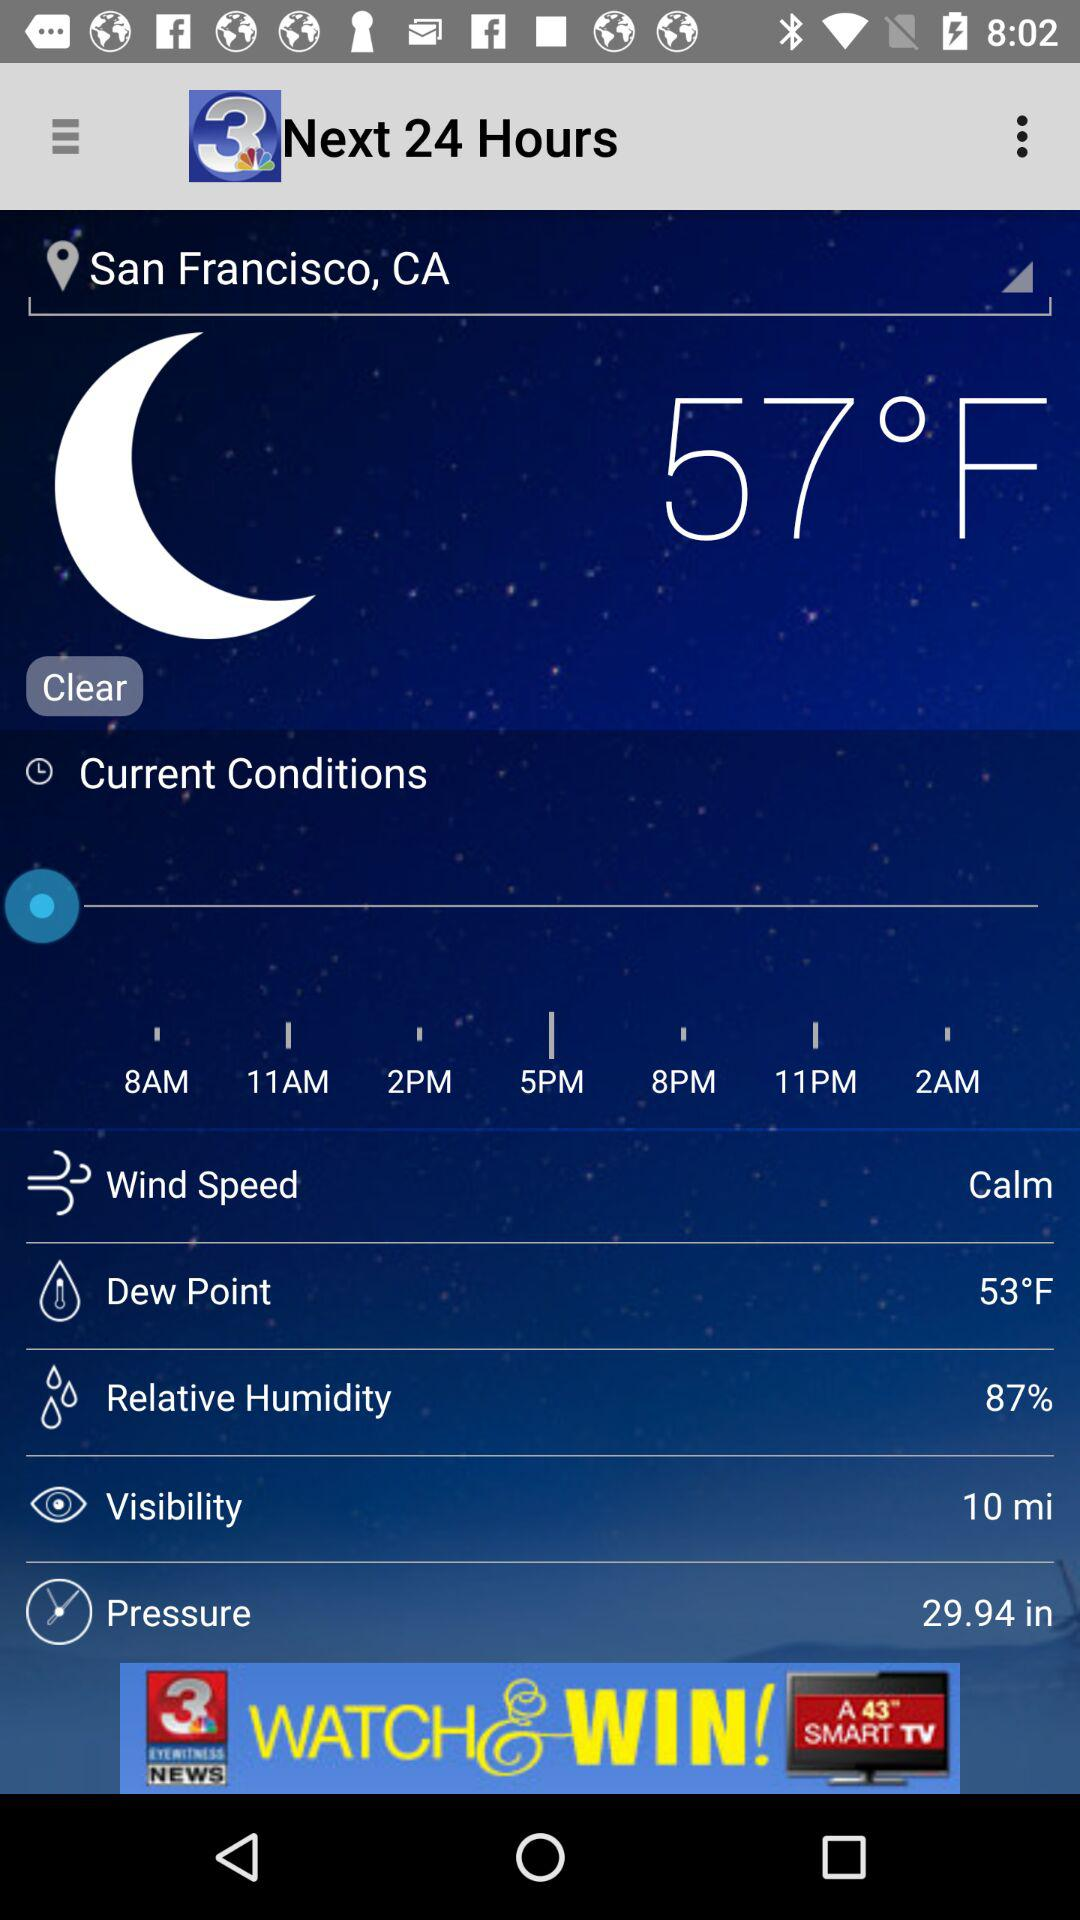What is the humidity level? The humidity level is 87%. 